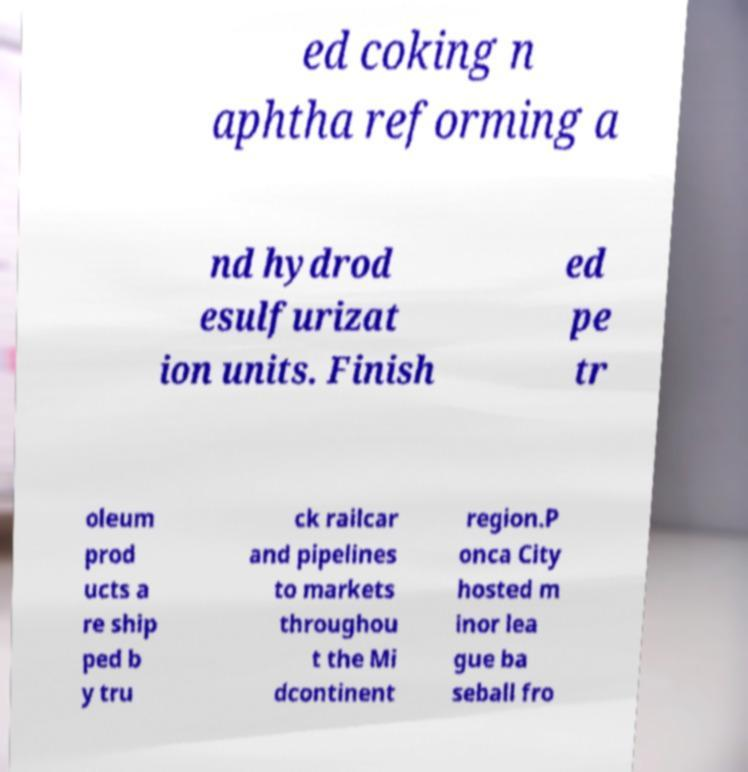I need the written content from this picture converted into text. Can you do that? ed coking n aphtha reforming a nd hydrod esulfurizat ion units. Finish ed pe tr oleum prod ucts a re ship ped b y tru ck railcar and pipelines to markets throughou t the Mi dcontinent region.P onca City hosted m inor lea gue ba seball fro 